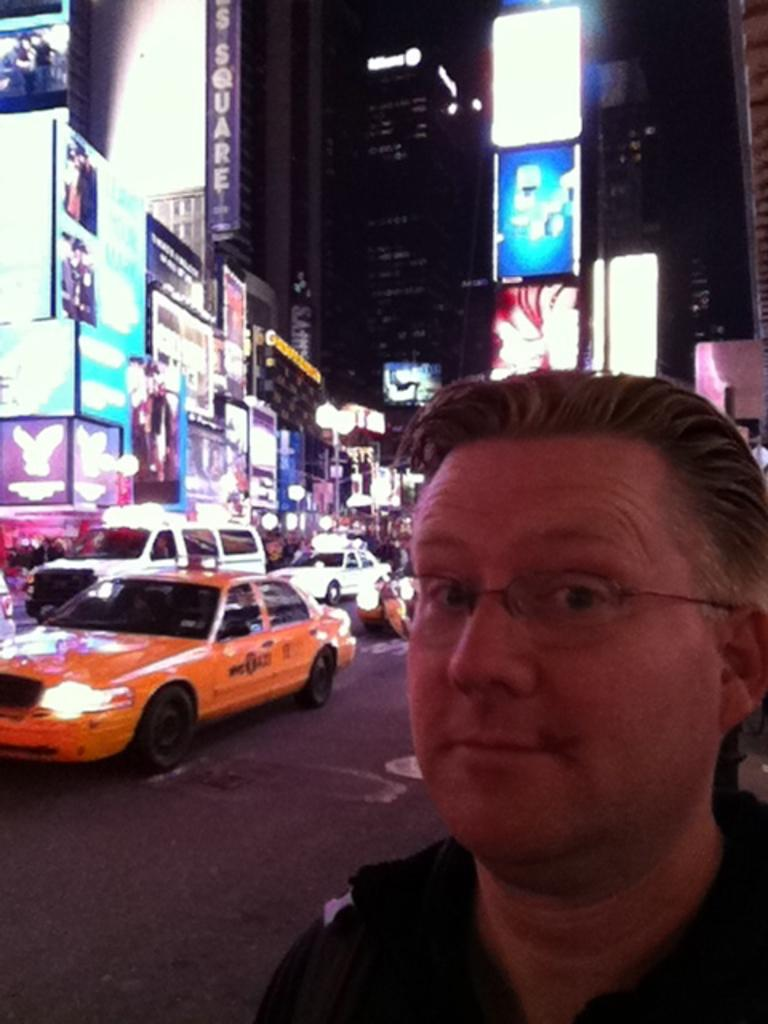Who is present in the image? There is a man in the image. What is the man doing in the image? The man is standing on the road. What else can be seen on the road in the image? Cars are visible in the image. What is visible in the background of the image? There are buildings in the image. What type of chalk is the man using to draw on the road in the image? There is no chalk present in the image, and the man is not drawing on the road. 